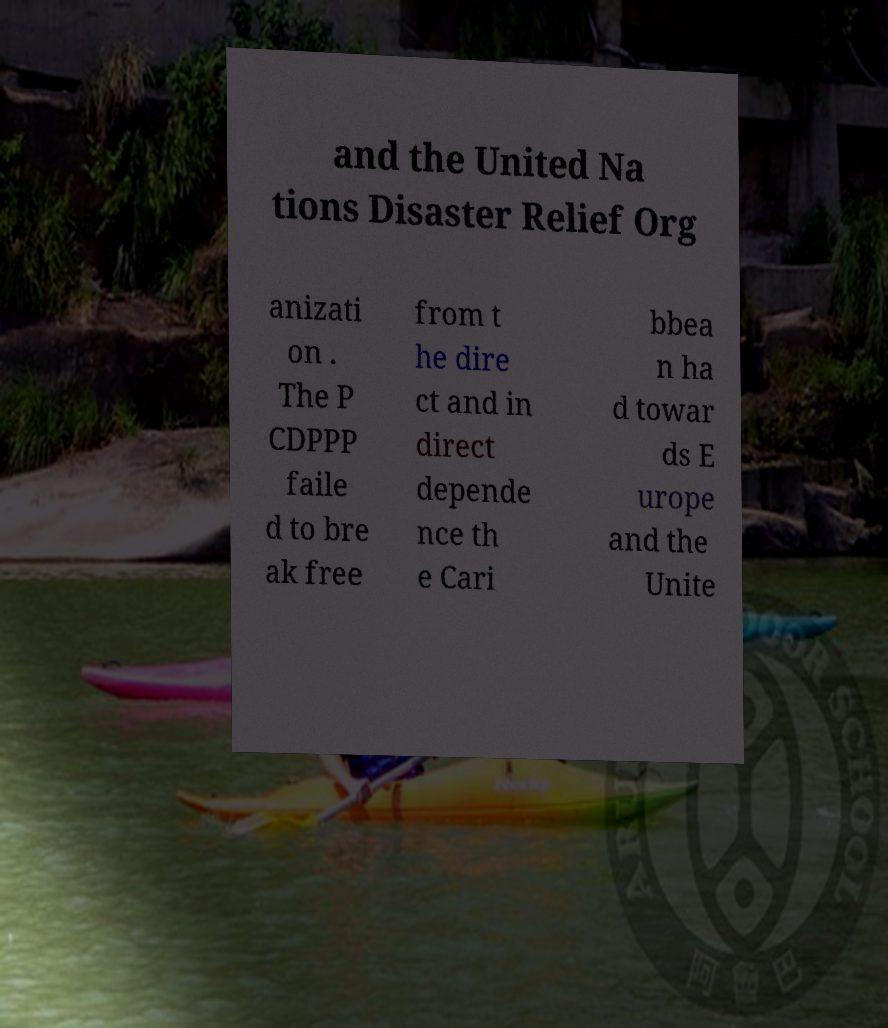For documentation purposes, I need the text within this image transcribed. Could you provide that? and the United Na tions Disaster Relief Org anizati on . The P CDPPP faile d to bre ak free from t he dire ct and in direct depende nce th e Cari bbea n ha d towar ds E urope and the Unite 